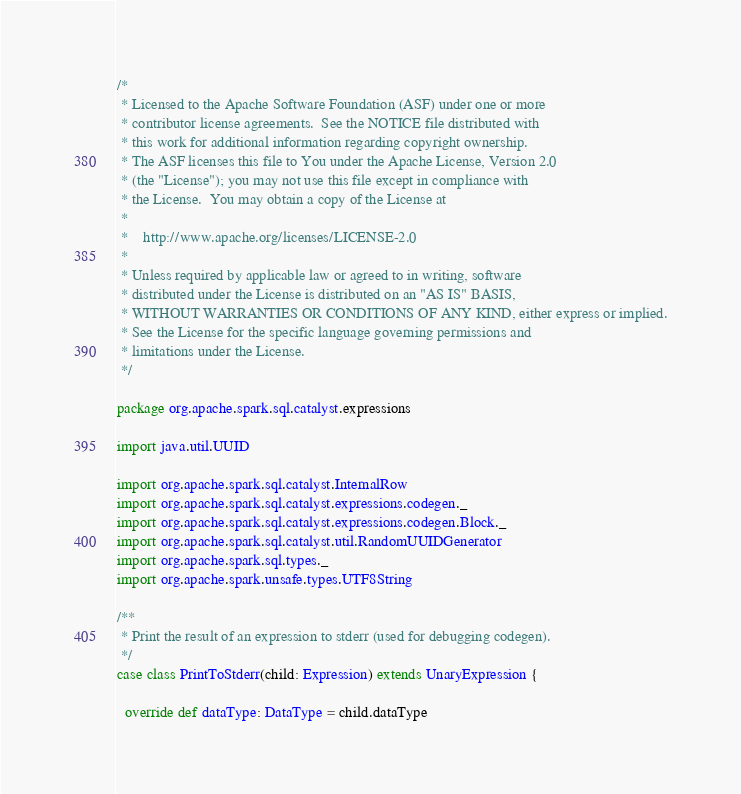<code> <loc_0><loc_0><loc_500><loc_500><_Scala_>/*
 * Licensed to the Apache Software Foundation (ASF) under one or more
 * contributor license agreements.  See the NOTICE file distributed with
 * this work for additional information regarding copyright ownership.
 * The ASF licenses this file to You under the Apache License, Version 2.0
 * (the "License"); you may not use this file except in compliance with
 * the License.  You may obtain a copy of the License at
 *
 *    http://www.apache.org/licenses/LICENSE-2.0
 *
 * Unless required by applicable law or agreed to in writing, software
 * distributed under the License is distributed on an "AS IS" BASIS,
 * WITHOUT WARRANTIES OR CONDITIONS OF ANY KIND, either express or implied.
 * See the License for the specific language governing permissions and
 * limitations under the License.
 */

package org.apache.spark.sql.catalyst.expressions

import java.util.UUID

import org.apache.spark.sql.catalyst.InternalRow
import org.apache.spark.sql.catalyst.expressions.codegen._
import org.apache.spark.sql.catalyst.expressions.codegen.Block._
import org.apache.spark.sql.catalyst.util.RandomUUIDGenerator
import org.apache.spark.sql.types._
import org.apache.spark.unsafe.types.UTF8String

/**
 * Print the result of an expression to stderr (used for debugging codegen).
 */
case class PrintToStderr(child: Expression) extends UnaryExpression {

  override def dataType: DataType = child.dataType
</code> 